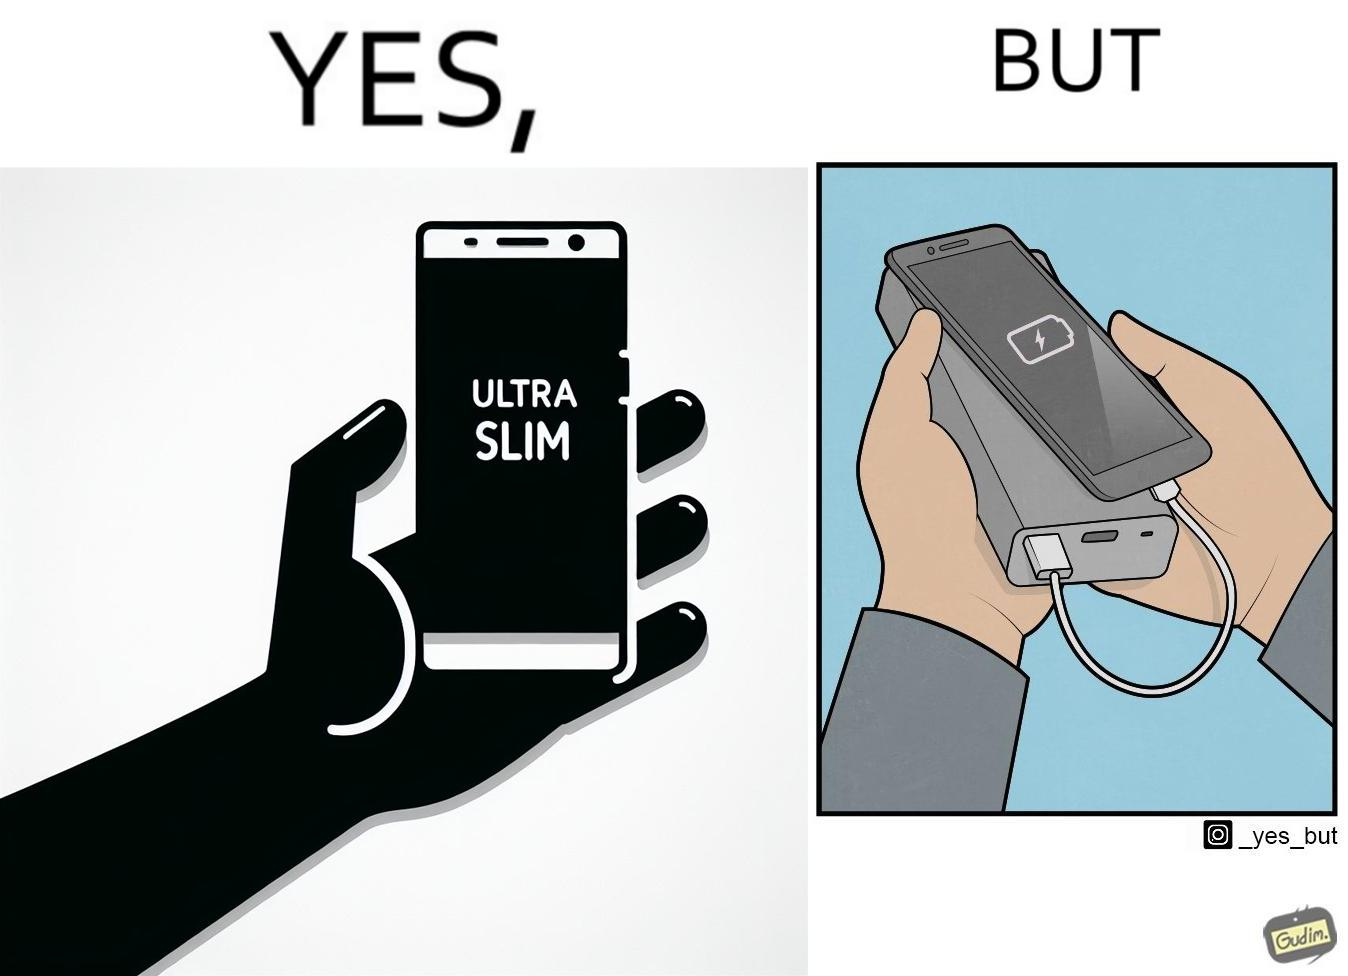Explain the humor or irony in this image. The image is satirical because even though the mobile phone has been developed to be very slim, it requires frequent recharging which makes the mobile phone useless without a big, heavy and thick power bank. 